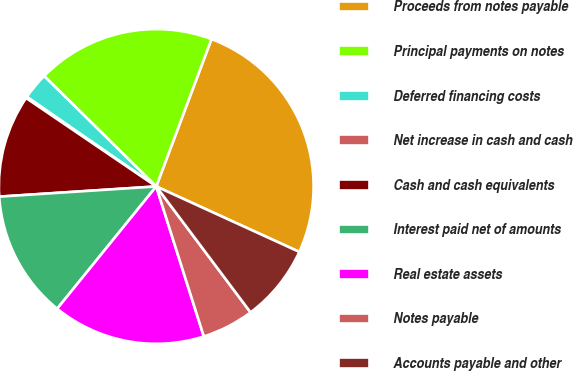<chart> <loc_0><loc_0><loc_500><loc_500><pie_chart><fcel>Proceeds from notes payable<fcel>Principal payments on notes<fcel>Deferred financing costs<fcel>Net increase in cash and cash<fcel>Cash and cash equivalents<fcel>Interest paid net of amounts<fcel>Real estate assets<fcel>Notes payable<fcel>Accounts payable and other<nl><fcel>26.12%<fcel>18.33%<fcel>2.74%<fcel>0.14%<fcel>10.53%<fcel>13.13%<fcel>15.73%<fcel>5.34%<fcel>7.94%<nl></chart> 